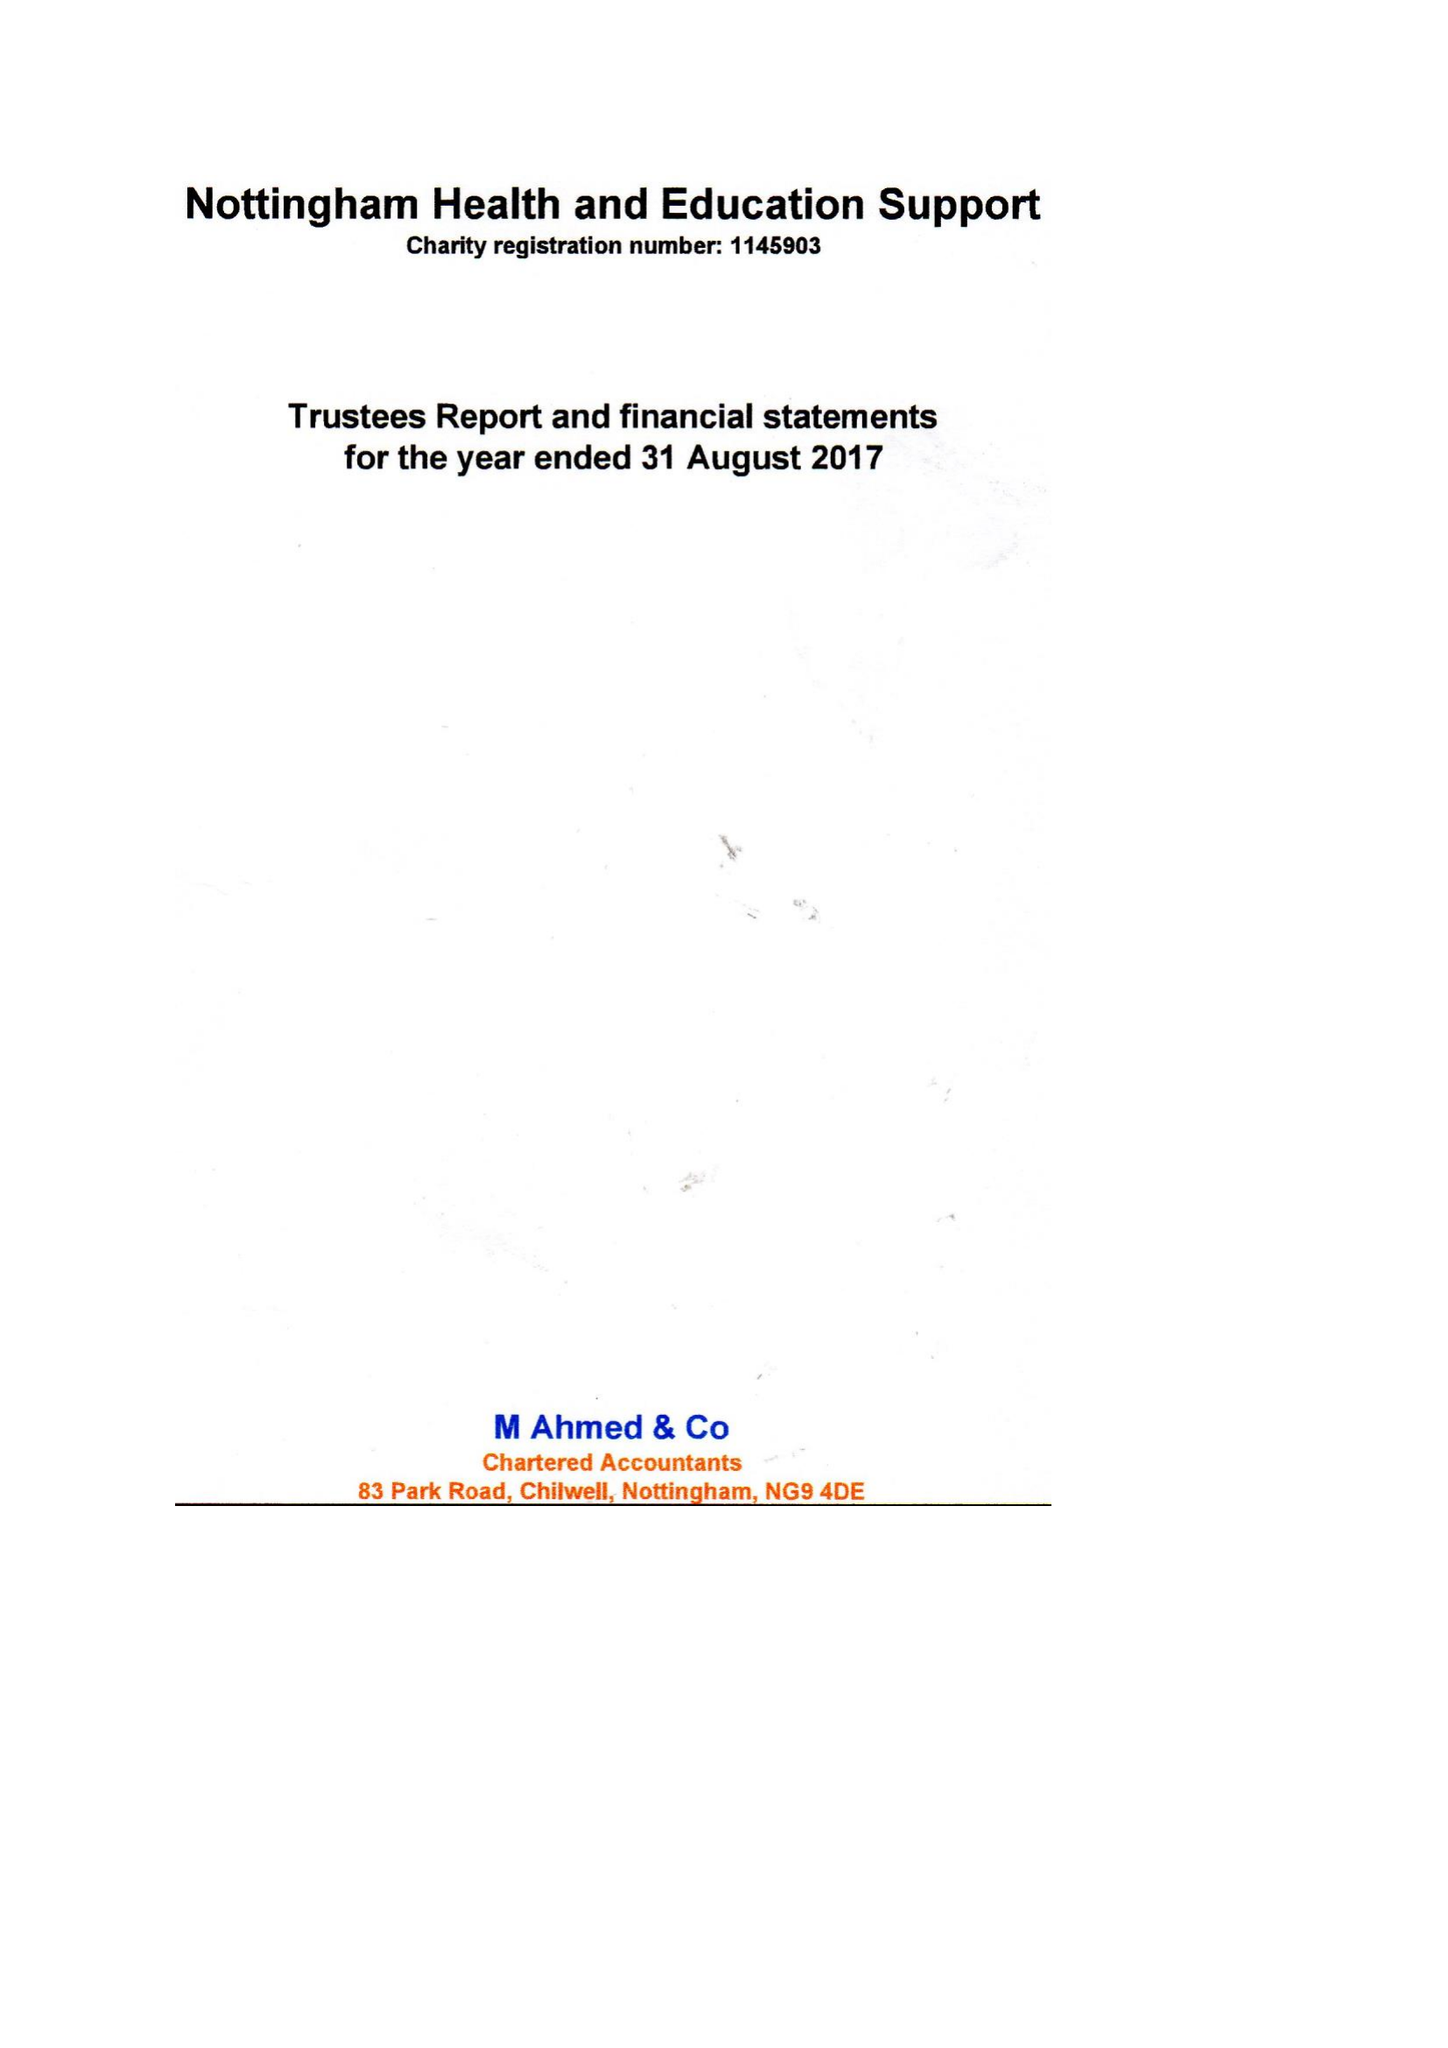What is the value for the address__post_town?
Answer the question using a single word or phrase. NOTTINGHAM 